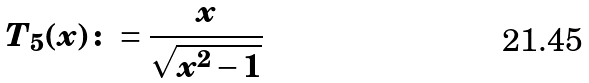<formula> <loc_0><loc_0><loc_500><loc_500>T _ { 5 } ( x ) \colon = \frac { x } { \sqrt { x ^ { 2 } - 1 } }</formula> 